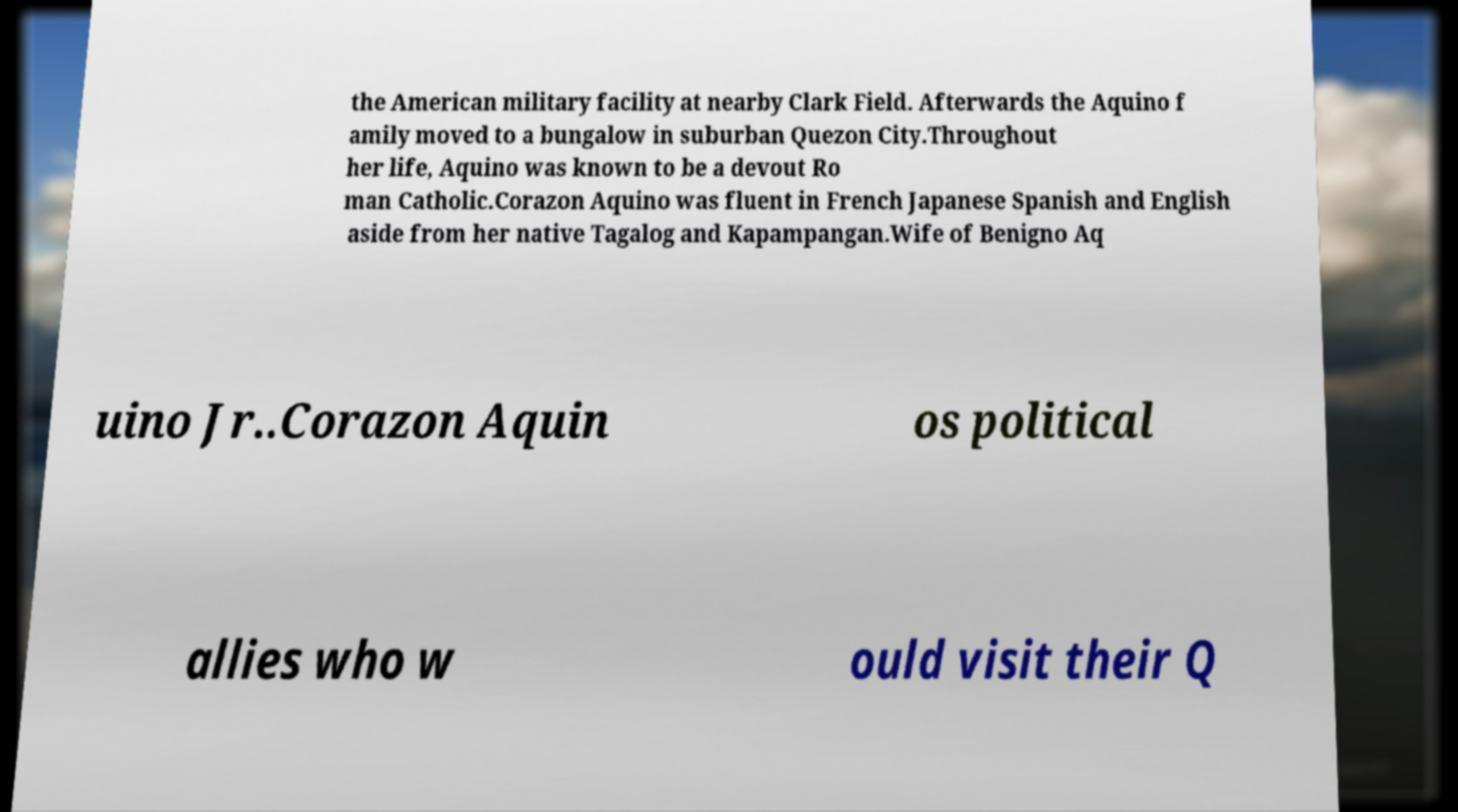There's text embedded in this image that I need extracted. Can you transcribe it verbatim? the American military facility at nearby Clark Field. Afterwards the Aquino f amily moved to a bungalow in suburban Quezon City.Throughout her life, Aquino was known to be a devout Ro man Catholic.Corazon Aquino was fluent in French Japanese Spanish and English aside from her native Tagalog and Kapampangan.Wife of Benigno Aq uino Jr..Corazon Aquin os political allies who w ould visit their Q 